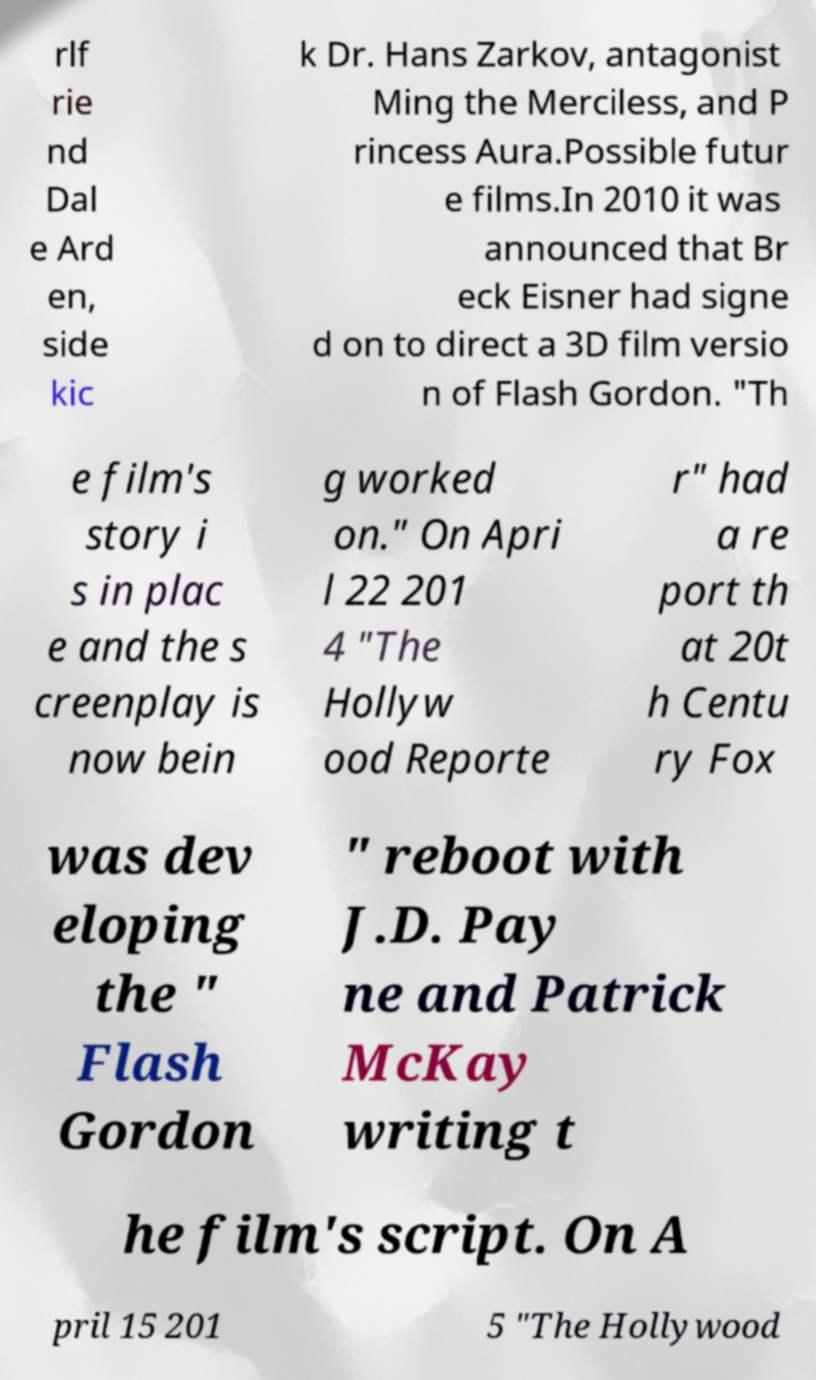For documentation purposes, I need the text within this image transcribed. Could you provide that? rlf rie nd Dal e Ard en, side kic k Dr. Hans Zarkov, antagonist Ming the Merciless, and P rincess Aura.Possible futur e films.In 2010 it was announced that Br eck Eisner had signe d on to direct a 3D film versio n of Flash Gordon. "Th e film's story i s in plac e and the s creenplay is now bein g worked on." On Apri l 22 201 4 "The Hollyw ood Reporte r" had a re port th at 20t h Centu ry Fox was dev eloping the " Flash Gordon " reboot with J.D. Pay ne and Patrick McKay writing t he film's script. On A pril 15 201 5 "The Hollywood 